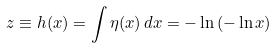Convert formula to latex. <formula><loc_0><loc_0><loc_500><loc_500>z \equiv h ( x ) = \int \eta ( x ) \, d x = - \ln { ( - \ln { x } ) }</formula> 